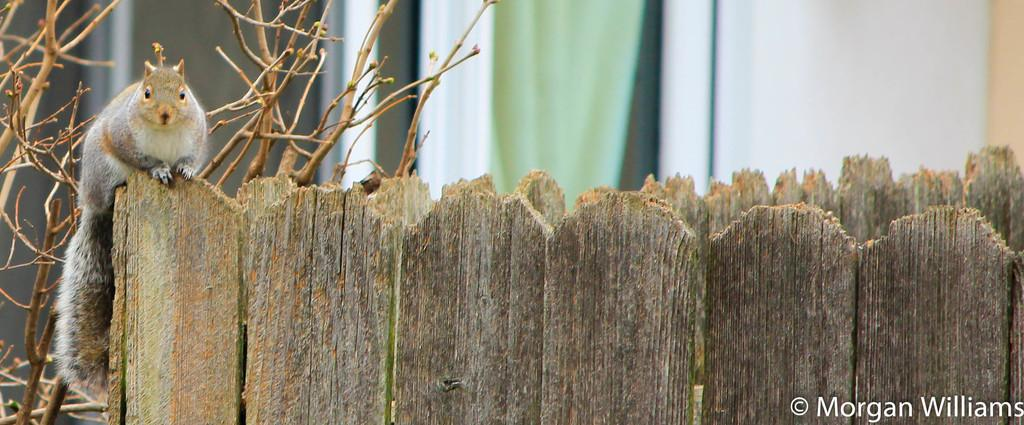What animal can be seen in the image? There is a squirrel in the image. Where is the squirrel located? The squirrel is sitting on a wooden fence. What can be seen in the background of the image? There are plants and a wall in the background of the image. What is the weight of the cup on the squirrel's head in the image? There is no cup on the squirrel's head in the image, so it is not possible to determine its weight. 